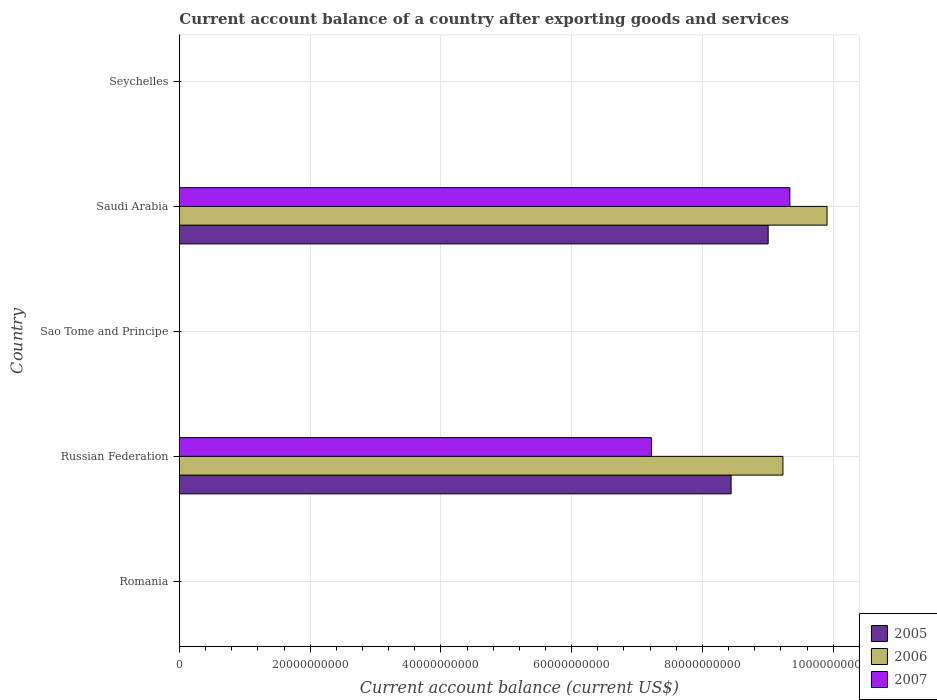How many different coloured bars are there?
Provide a short and direct response. 3. Are the number of bars per tick equal to the number of legend labels?
Offer a very short reply. No. What is the label of the 4th group of bars from the top?
Your answer should be compact. Russian Federation. In how many cases, is the number of bars for a given country not equal to the number of legend labels?
Your response must be concise. 3. Across all countries, what is the maximum account balance in 2005?
Your answer should be very brief. 9.01e+1. Across all countries, what is the minimum account balance in 2005?
Keep it short and to the point. 0. In which country was the account balance in 2005 maximum?
Make the answer very short. Saudi Arabia. What is the total account balance in 2007 in the graph?
Your response must be concise. 1.66e+11. What is the difference between the account balance in 2007 in Romania and the account balance in 2006 in Sao Tome and Principe?
Your answer should be compact. 0. What is the average account balance in 2006 per country?
Provide a succinct answer. 3.83e+1. What is the difference between the account balance in 2005 and account balance in 2007 in Saudi Arabia?
Ensure brevity in your answer.  -3.32e+09. What is the difference between the highest and the lowest account balance in 2005?
Ensure brevity in your answer.  9.01e+1. In how many countries, is the account balance in 2007 greater than the average account balance in 2007 taken over all countries?
Make the answer very short. 2. What is the difference between two consecutive major ticks on the X-axis?
Keep it short and to the point. 2.00e+1. Does the graph contain any zero values?
Ensure brevity in your answer.  Yes. Does the graph contain grids?
Keep it short and to the point. Yes. Where does the legend appear in the graph?
Provide a succinct answer. Bottom right. How are the legend labels stacked?
Your answer should be very brief. Vertical. What is the title of the graph?
Give a very brief answer. Current account balance of a country after exporting goods and services. What is the label or title of the X-axis?
Keep it short and to the point. Current account balance (current US$). What is the Current account balance (current US$) of 2006 in Romania?
Offer a very short reply. 0. What is the Current account balance (current US$) of 2005 in Russian Federation?
Provide a short and direct response. 8.44e+1. What is the Current account balance (current US$) of 2006 in Russian Federation?
Your answer should be very brief. 9.23e+1. What is the Current account balance (current US$) in 2007 in Russian Federation?
Your answer should be compact. 7.22e+1. What is the Current account balance (current US$) in 2006 in Sao Tome and Principe?
Your response must be concise. 0. What is the Current account balance (current US$) of 2005 in Saudi Arabia?
Offer a terse response. 9.01e+1. What is the Current account balance (current US$) in 2006 in Saudi Arabia?
Offer a terse response. 9.91e+1. What is the Current account balance (current US$) of 2007 in Saudi Arabia?
Give a very brief answer. 9.34e+1. What is the Current account balance (current US$) of 2007 in Seychelles?
Your response must be concise. 0. Across all countries, what is the maximum Current account balance (current US$) of 2005?
Provide a short and direct response. 9.01e+1. Across all countries, what is the maximum Current account balance (current US$) of 2006?
Your response must be concise. 9.91e+1. Across all countries, what is the maximum Current account balance (current US$) of 2007?
Offer a very short reply. 9.34e+1. Across all countries, what is the minimum Current account balance (current US$) of 2005?
Give a very brief answer. 0. Across all countries, what is the minimum Current account balance (current US$) in 2007?
Give a very brief answer. 0. What is the total Current account balance (current US$) in 2005 in the graph?
Make the answer very short. 1.74e+11. What is the total Current account balance (current US$) in 2006 in the graph?
Keep it short and to the point. 1.91e+11. What is the total Current account balance (current US$) in 2007 in the graph?
Make the answer very short. 1.66e+11. What is the difference between the Current account balance (current US$) of 2005 in Russian Federation and that in Saudi Arabia?
Your response must be concise. -5.67e+09. What is the difference between the Current account balance (current US$) in 2006 in Russian Federation and that in Saudi Arabia?
Provide a succinct answer. -6.75e+09. What is the difference between the Current account balance (current US$) of 2007 in Russian Federation and that in Saudi Arabia?
Provide a short and direct response. -2.12e+1. What is the difference between the Current account balance (current US$) in 2005 in Russian Federation and the Current account balance (current US$) in 2006 in Saudi Arabia?
Offer a very short reply. -1.47e+1. What is the difference between the Current account balance (current US$) in 2005 in Russian Federation and the Current account balance (current US$) in 2007 in Saudi Arabia?
Make the answer very short. -8.99e+09. What is the difference between the Current account balance (current US$) of 2006 in Russian Federation and the Current account balance (current US$) of 2007 in Saudi Arabia?
Offer a terse response. -1.06e+09. What is the average Current account balance (current US$) in 2005 per country?
Give a very brief answer. 3.49e+1. What is the average Current account balance (current US$) of 2006 per country?
Ensure brevity in your answer.  3.83e+1. What is the average Current account balance (current US$) of 2007 per country?
Your answer should be very brief. 3.31e+1. What is the difference between the Current account balance (current US$) in 2005 and Current account balance (current US$) in 2006 in Russian Federation?
Provide a succinct answer. -7.93e+09. What is the difference between the Current account balance (current US$) in 2005 and Current account balance (current US$) in 2007 in Russian Federation?
Provide a short and direct response. 1.22e+1. What is the difference between the Current account balance (current US$) of 2006 and Current account balance (current US$) of 2007 in Russian Federation?
Provide a short and direct response. 2.01e+1. What is the difference between the Current account balance (current US$) in 2005 and Current account balance (current US$) in 2006 in Saudi Arabia?
Offer a terse response. -9.01e+09. What is the difference between the Current account balance (current US$) of 2005 and Current account balance (current US$) of 2007 in Saudi Arabia?
Your answer should be very brief. -3.32e+09. What is the difference between the Current account balance (current US$) of 2006 and Current account balance (current US$) of 2007 in Saudi Arabia?
Provide a succinct answer. 5.69e+09. What is the ratio of the Current account balance (current US$) in 2005 in Russian Federation to that in Saudi Arabia?
Your answer should be very brief. 0.94. What is the ratio of the Current account balance (current US$) of 2006 in Russian Federation to that in Saudi Arabia?
Provide a short and direct response. 0.93. What is the ratio of the Current account balance (current US$) of 2007 in Russian Federation to that in Saudi Arabia?
Offer a terse response. 0.77. What is the difference between the highest and the lowest Current account balance (current US$) of 2005?
Ensure brevity in your answer.  9.01e+1. What is the difference between the highest and the lowest Current account balance (current US$) in 2006?
Provide a short and direct response. 9.91e+1. What is the difference between the highest and the lowest Current account balance (current US$) of 2007?
Offer a very short reply. 9.34e+1. 